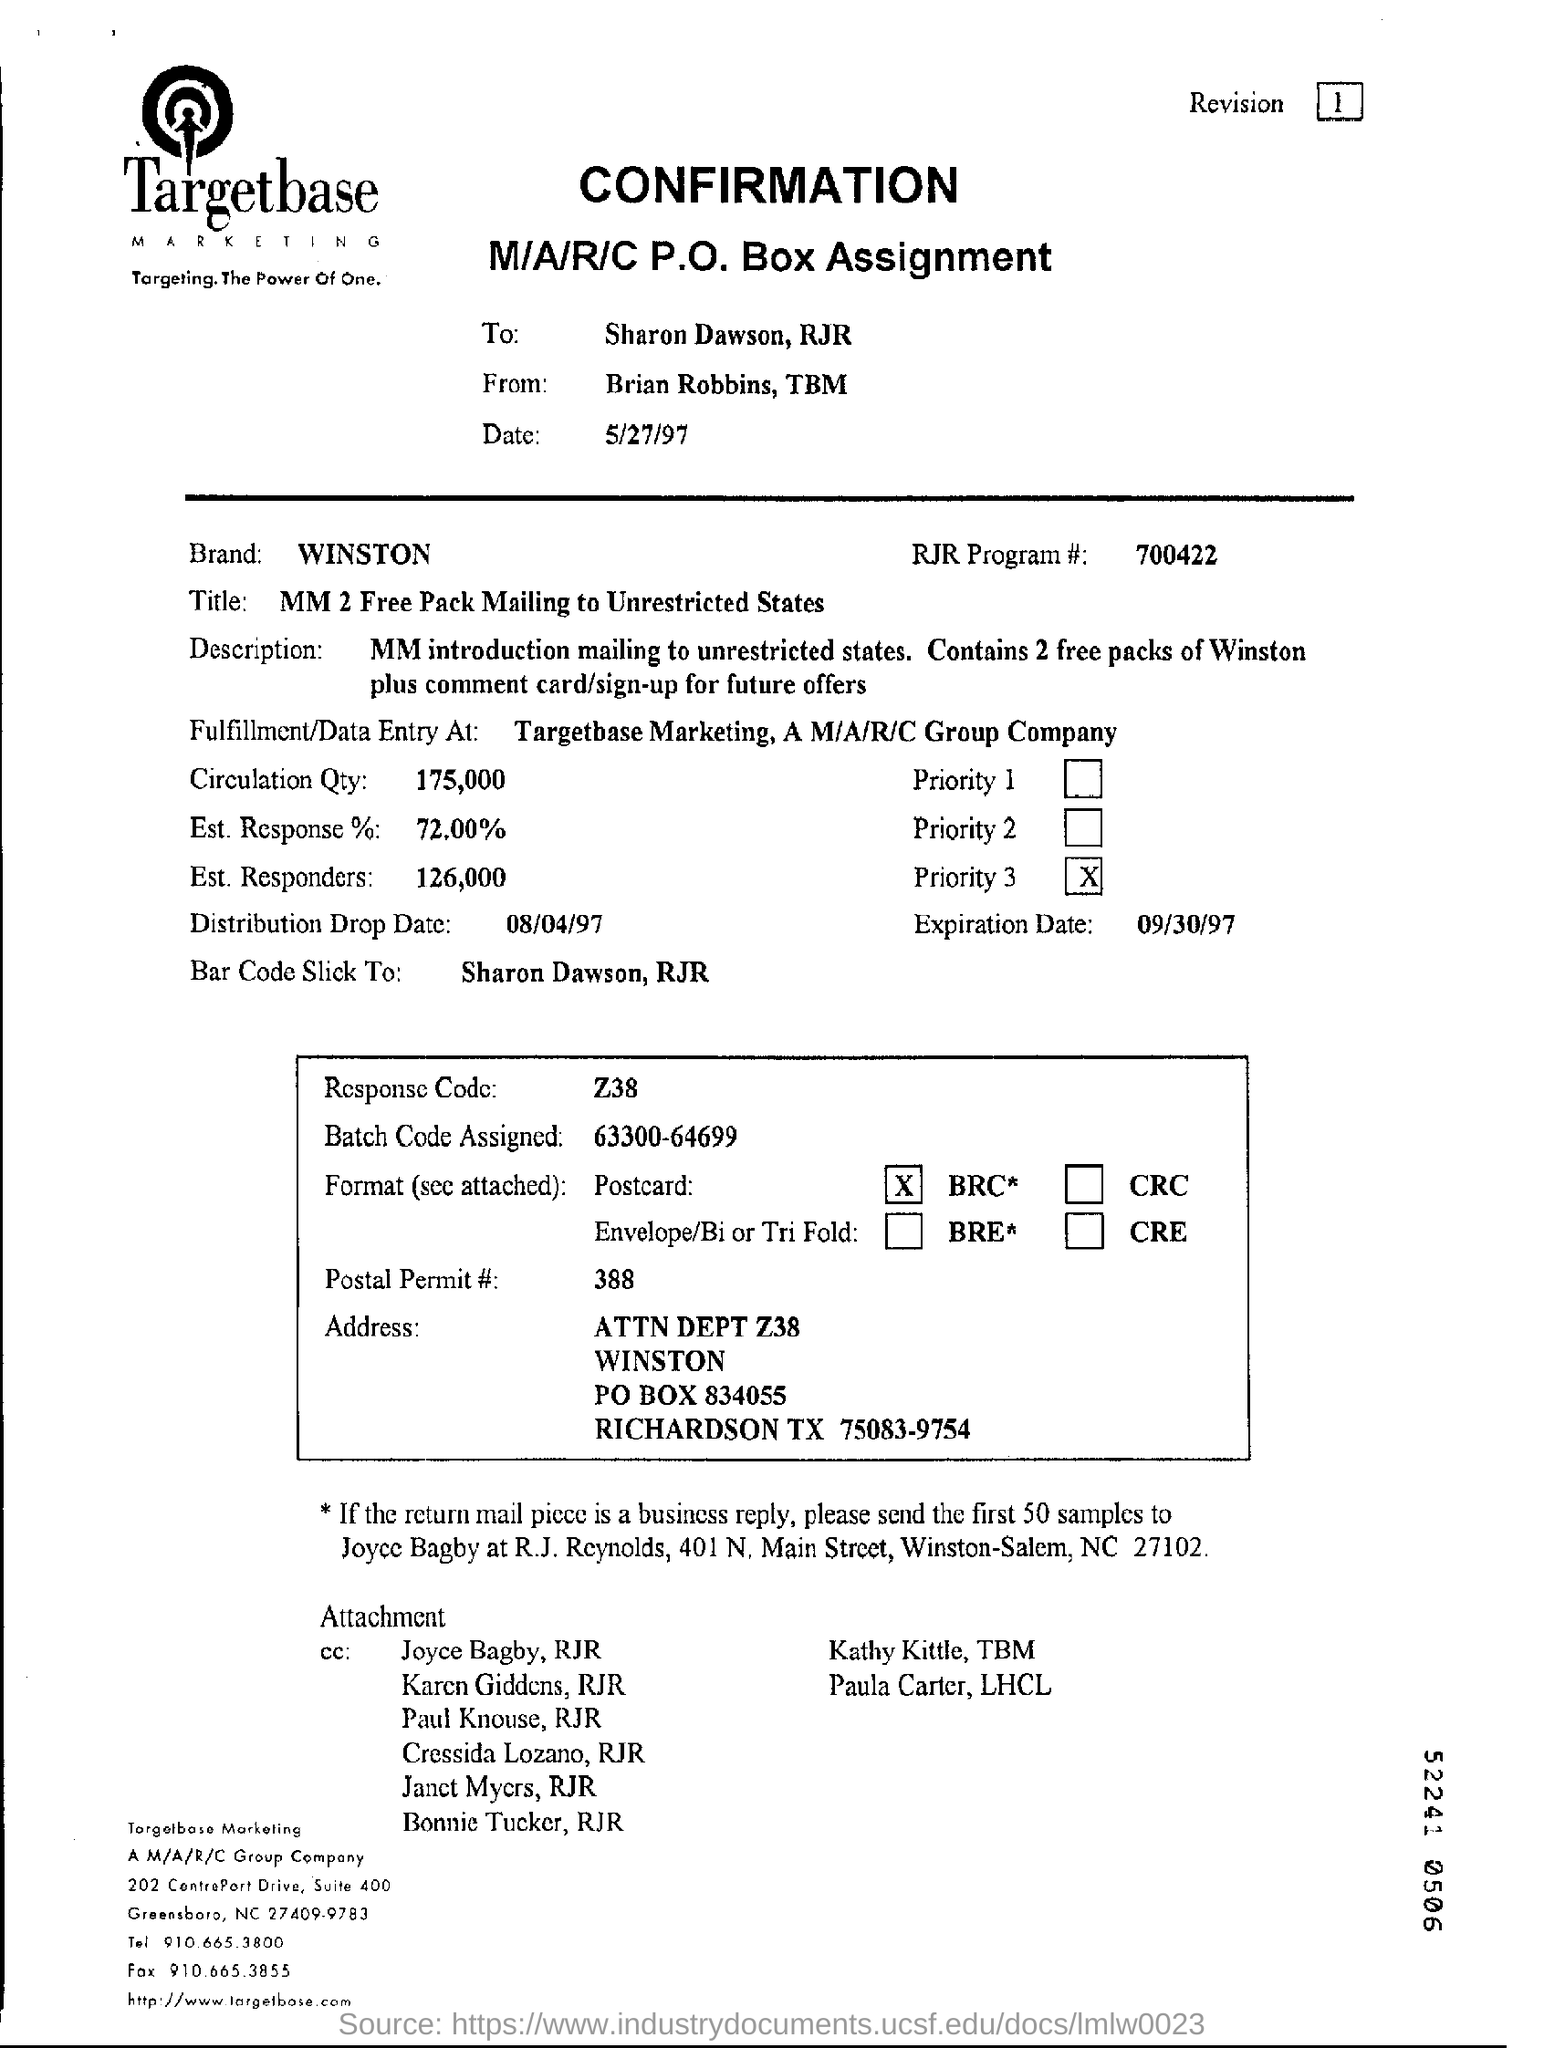Mention a couple of crucial points in this snapshot. The quantity of circulation is 175,000. The response code is Z38. The expiration date is September 30, 1997. The date of confirmation is May 27, 1997. The estimated response rate is 72%. 